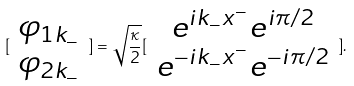Convert formula to latex. <formula><loc_0><loc_0><loc_500><loc_500>[ \begin{array} { c } \varphi _ { 1 k _ { - } } \\ \varphi _ { 2 k _ { - } } \end{array} ] = \sqrt { \frac { \kappa } { 2 } } [ \begin{array} { c } e ^ { i k _ { - } x ^ { - } } e ^ { i \pi / 2 } \\ e ^ { - i k _ { - } x ^ { - } } e ^ { - i \pi / 2 } \end{array} ] .</formula> 